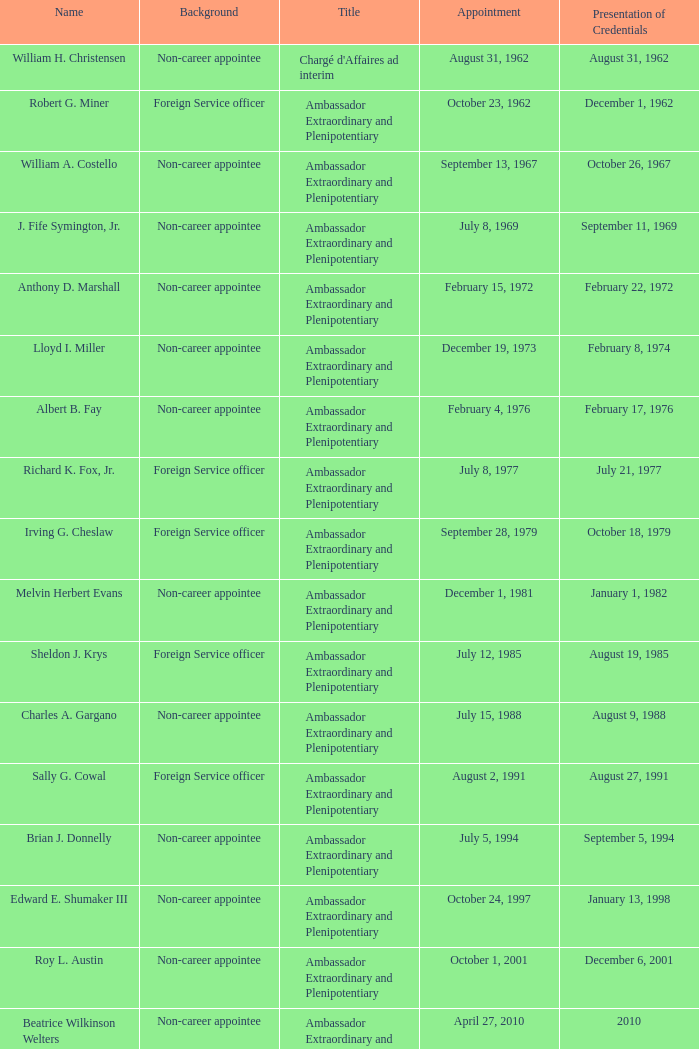What was Anthony D. Marshall's title? Ambassador Extraordinary and Plenipotentiary. 